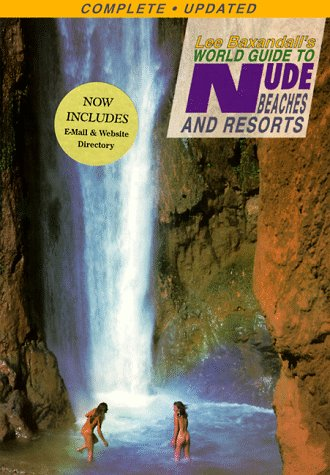Who wrote this book? Lee Baxandall is the author of this engaging travel guide focused on naturist locations. 